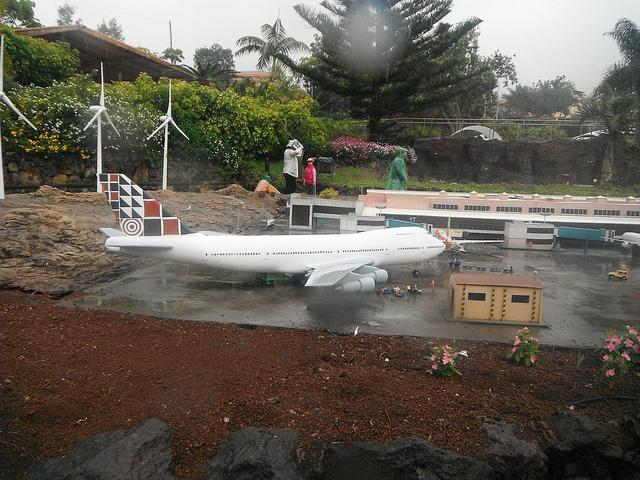What is this place?

Choices:
A) rodeo
B) amusement park
C) airport
D) daycare amusement park 